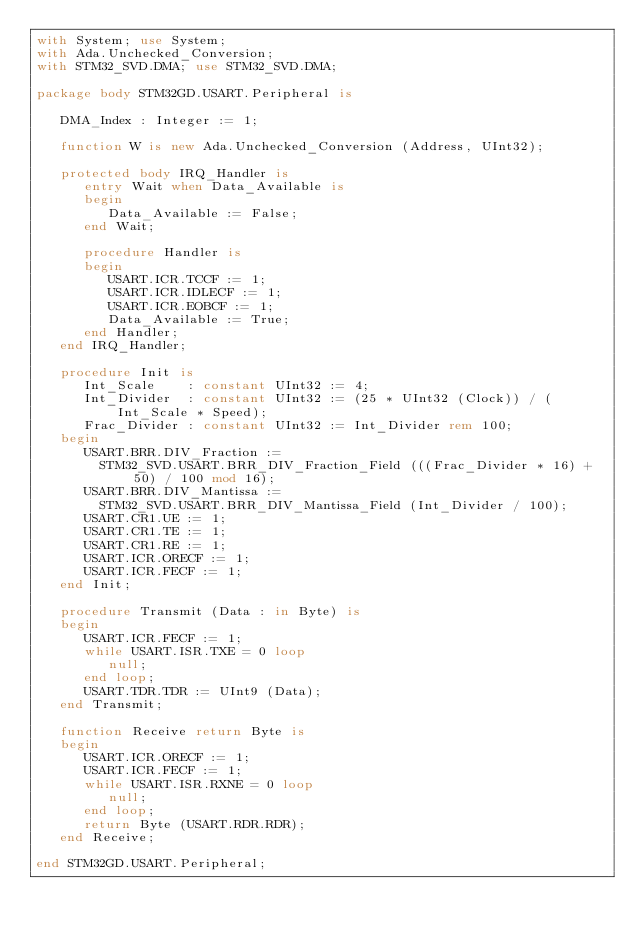<code> <loc_0><loc_0><loc_500><loc_500><_Ada_>with System; use System;
with Ada.Unchecked_Conversion;
with STM32_SVD.DMA; use STM32_SVD.DMA;

package body STM32GD.USART.Peripheral is

   DMA_Index : Integer := 1;

   function W is new Ada.Unchecked_Conversion (Address, UInt32);

   protected body IRQ_Handler is
      entry Wait when Data_Available is
      begin
         Data_Available := False;
      end Wait;

      procedure Handler is
      begin
         USART.ICR.TCCF := 1;
         USART.ICR.IDLECF := 1;
         USART.ICR.EOBCF := 1;
         Data_Available := True;
      end Handler;
   end IRQ_Handler;

   procedure Init is
      Int_Scale    : constant UInt32 := 4;
      Int_Divider  : constant UInt32 := (25 * UInt32 (Clock)) / (Int_Scale * Speed);
      Frac_Divider : constant UInt32 := Int_Divider rem 100;
   begin
      USART.BRR.DIV_Fraction :=
        STM32_SVD.USART.BRR_DIV_Fraction_Field (((Frac_Divider * 16) + 50) / 100 mod 16);
      USART.BRR.DIV_Mantissa :=
        STM32_SVD.USART.BRR_DIV_Mantissa_Field (Int_Divider / 100);
      USART.CR1.UE := 1;
      USART.CR1.TE := 1;
      USART.CR1.RE := 1;
      USART.ICR.ORECF := 1;
      USART.ICR.FECF := 1;
   end Init;

   procedure Transmit (Data : in Byte) is
   begin
      USART.ICR.FECF := 1;
      while USART.ISR.TXE = 0 loop
         null;
      end loop;
      USART.TDR.TDR := UInt9 (Data);
   end Transmit;

   function Receive return Byte is
   begin
      USART.ICR.ORECF := 1;
      USART.ICR.FECF := 1;
      while USART.ISR.RXNE = 0 loop
         null;
      end loop;
      return Byte (USART.RDR.RDR);
   end Receive;

end STM32GD.USART.Peripheral;
</code> 